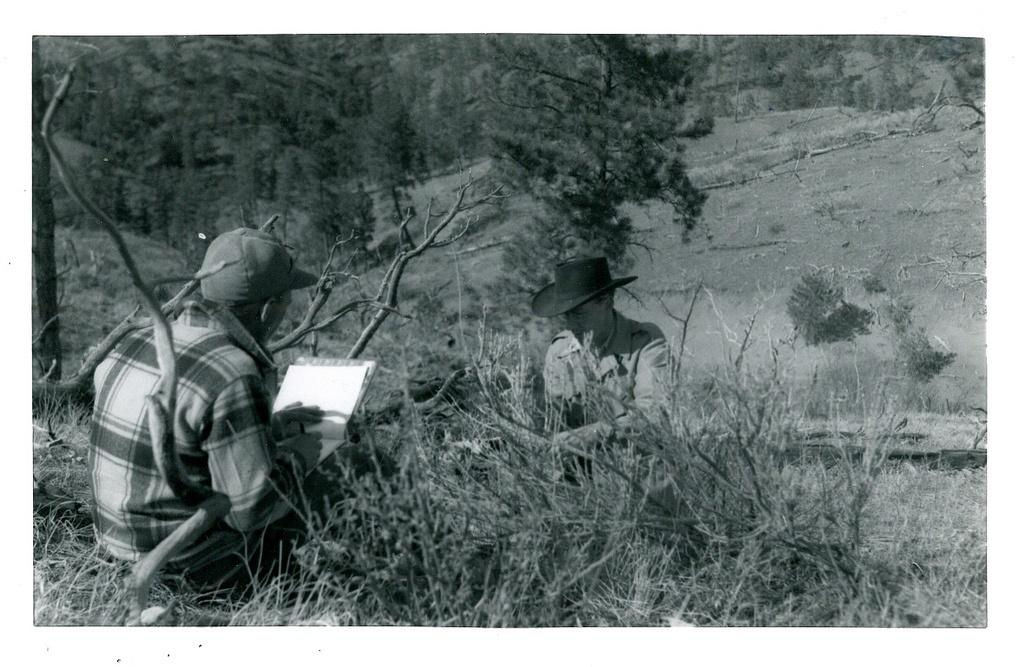How many people are in the image? There are two men in the image. What is one of the men holding? One of the men is holding a book. What can be seen in the background of the image? There are trees in the background of the image. What is the color scheme of the image? The image is in black and white color. What type of jewel is the dog carrying on the tray in the image? There is no dog or tray present in the image, and therefore no such activity or object can be observed. 